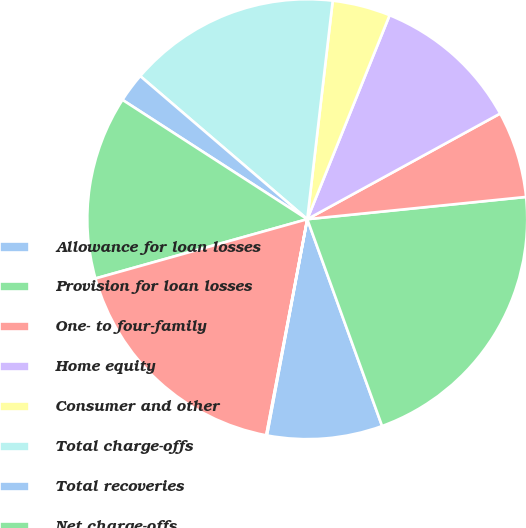Convert chart to OTSL. <chart><loc_0><loc_0><loc_500><loc_500><pie_chart><fcel>Allowance for loan losses<fcel>Provision for loan losses<fcel>One- to four-family<fcel>Home equity<fcel>Consumer and other<fcel>Total charge-offs<fcel>Total recoveries<fcel>Net charge-offs<fcel>Allowance for loan losses end<fcel>Net charge-offs to average<nl><fcel>8.46%<fcel>21.09%<fcel>6.36%<fcel>10.92%<fcel>4.26%<fcel>15.57%<fcel>2.15%<fcel>13.47%<fcel>17.67%<fcel>0.05%<nl></chart> 